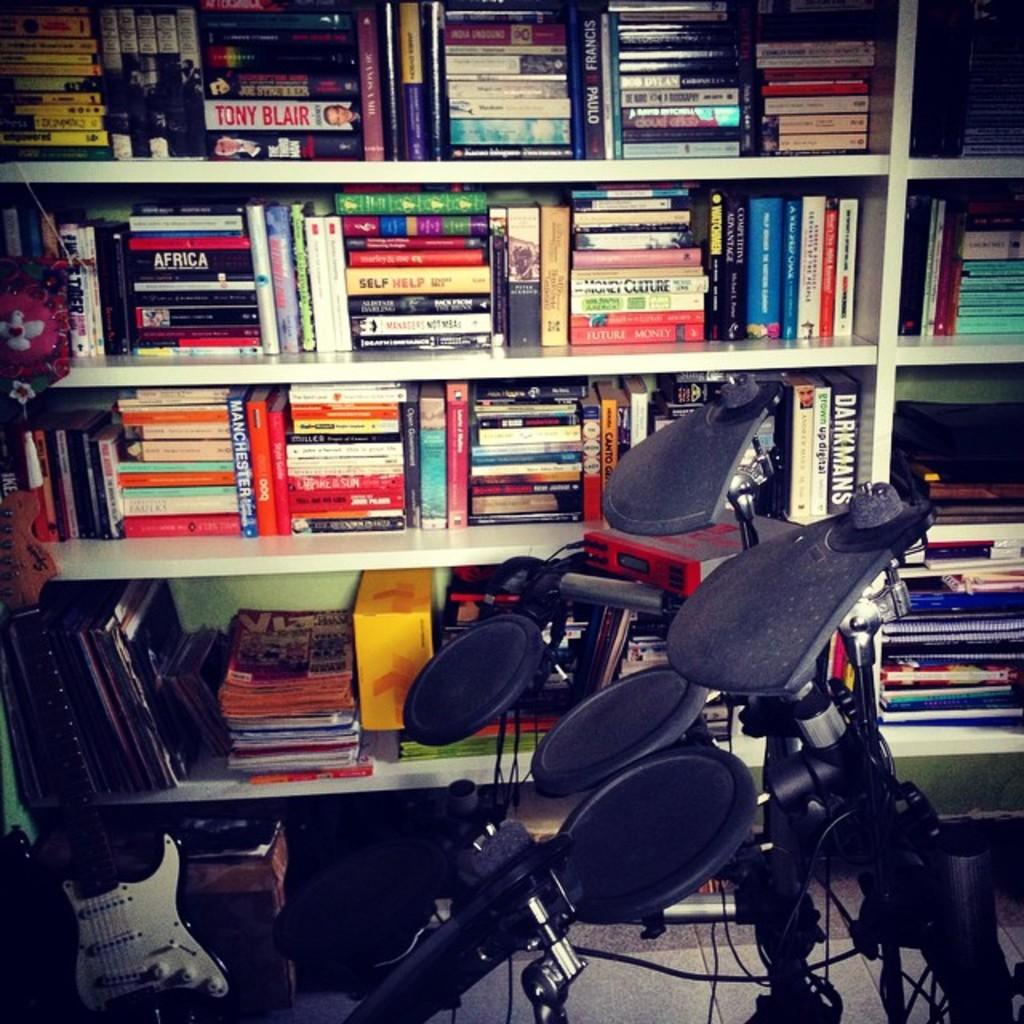Provide a one-sentence caption for the provided image. Book shelves include the title Self Help on a yellow book and many others. 